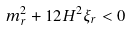<formula> <loc_0><loc_0><loc_500><loc_500>m _ { r } ^ { 2 } + 1 2 H ^ { 2 } \xi _ { r } < 0</formula> 